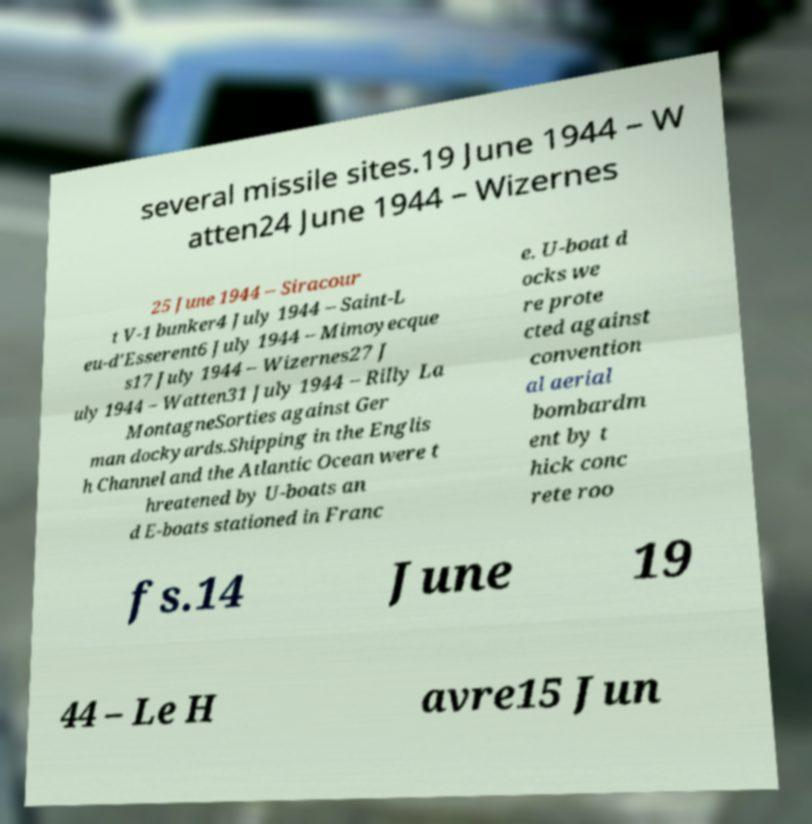Can you read and provide the text displayed in the image?This photo seems to have some interesting text. Can you extract and type it out for me? several missile sites.19 June 1944 – W atten24 June 1944 – Wizernes 25 June 1944 – Siracour t V-1 bunker4 July 1944 – Saint-L eu-d'Esserent6 July 1944 – Mimoyecque s17 July 1944 – Wizernes27 J uly 1944 – Watten31 July 1944 – Rilly La MontagneSorties against Ger man dockyards.Shipping in the Englis h Channel and the Atlantic Ocean were t hreatened by U-boats an d E-boats stationed in Franc e. U-boat d ocks we re prote cted against convention al aerial bombardm ent by t hick conc rete roo fs.14 June 19 44 – Le H avre15 Jun 